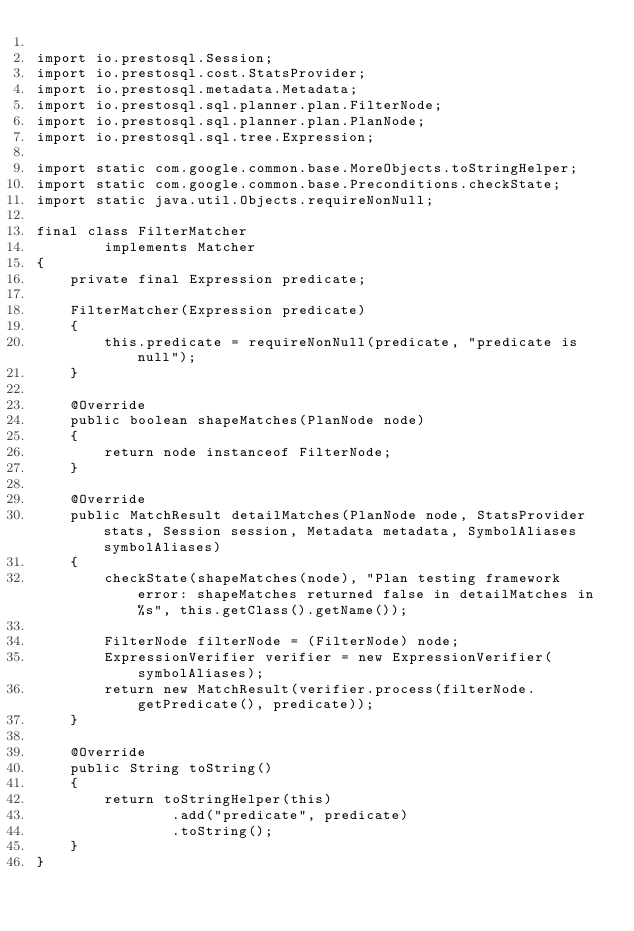Convert code to text. <code><loc_0><loc_0><loc_500><loc_500><_Java_>
import io.prestosql.Session;
import io.prestosql.cost.StatsProvider;
import io.prestosql.metadata.Metadata;
import io.prestosql.sql.planner.plan.FilterNode;
import io.prestosql.sql.planner.plan.PlanNode;
import io.prestosql.sql.tree.Expression;

import static com.google.common.base.MoreObjects.toStringHelper;
import static com.google.common.base.Preconditions.checkState;
import static java.util.Objects.requireNonNull;

final class FilterMatcher
        implements Matcher
{
    private final Expression predicate;

    FilterMatcher(Expression predicate)
    {
        this.predicate = requireNonNull(predicate, "predicate is null");
    }

    @Override
    public boolean shapeMatches(PlanNode node)
    {
        return node instanceof FilterNode;
    }

    @Override
    public MatchResult detailMatches(PlanNode node, StatsProvider stats, Session session, Metadata metadata, SymbolAliases symbolAliases)
    {
        checkState(shapeMatches(node), "Plan testing framework error: shapeMatches returned false in detailMatches in %s", this.getClass().getName());

        FilterNode filterNode = (FilterNode) node;
        ExpressionVerifier verifier = new ExpressionVerifier(symbolAliases);
        return new MatchResult(verifier.process(filterNode.getPredicate(), predicate));
    }

    @Override
    public String toString()
    {
        return toStringHelper(this)
                .add("predicate", predicate)
                .toString();
    }
}
</code> 